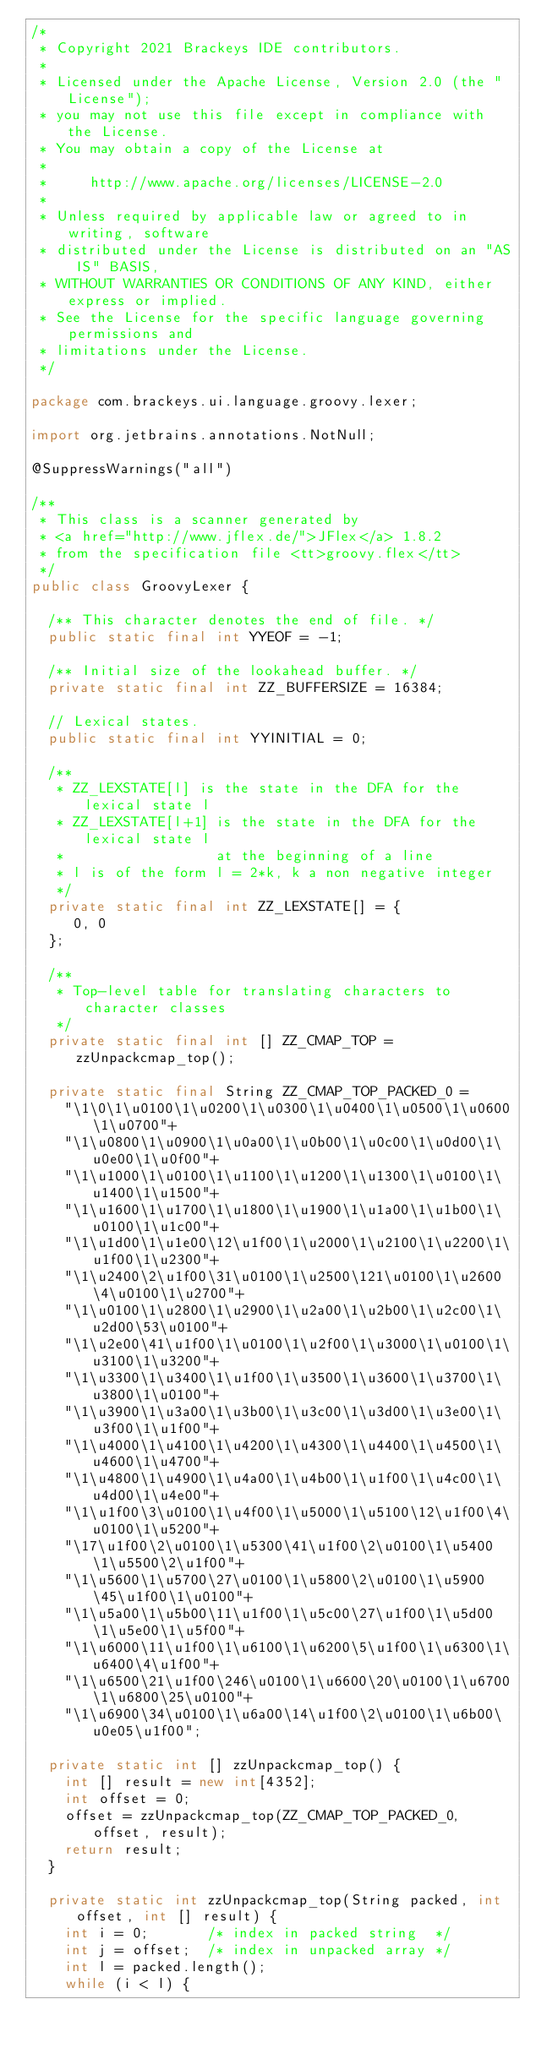Convert code to text. <code><loc_0><loc_0><loc_500><loc_500><_Java_>/*
 * Copyright 2021 Brackeys IDE contributors.
 *
 * Licensed under the Apache License, Version 2.0 (the "License");
 * you may not use this file except in compliance with the License.
 * You may obtain a copy of the License at
 *
 *     http://www.apache.org/licenses/LICENSE-2.0
 *
 * Unless required by applicable law or agreed to in writing, software
 * distributed under the License is distributed on an "AS IS" BASIS,
 * WITHOUT WARRANTIES OR CONDITIONS OF ANY KIND, either express or implied.
 * See the License for the specific language governing permissions and
 * limitations under the License.
 */

package com.brackeys.ui.language.groovy.lexer;

import org.jetbrains.annotations.NotNull;

@SuppressWarnings("all")

/**
 * This class is a scanner generated by
 * <a href="http://www.jflex.de/">JFlex</a> 1.8.2
 * from the specification file <tt>groovy.flex</tt>
 */
public class GroovyLexer {

  /** This character denotes the end of file. */
  public static final int YYEOF = -1;

  /** Initial size of the lookahead buffer. */
  private static final int ZZ_BUFFERSIZE = 16384;

  // Lexical states.
  public static final int YYINITIAL = 0;

  /**
   * ZZ_LEXSTATE[l] is the state in the DFA for the lexical state l
   * ZZ_LEXSTATE[l+1] is the state in the DFA for the lexical state l
   *                  at the beginning of a line
   * l is of the form l = 2*k, k a non negative integer
   */
  private static final int ZZ_LEXSTATE[] = {
     0, 0
  };

  /**
   * Top-level table for translating characters to character classes
   */
  private static final int [] ZZ_CMAP_TOP = zzUnpackcmap_top();

  private static final String ZZ_CMAP_TOP_PACKED_0 =
    "\1\0\1\u0100\1\u0200\1\u0300\1\u0400\1\u0500\1\u0600\1\u0700"+
    "\1\u0800\1\u0900\1\u0a00\1\u0b00\1\u0c00\1\u0d00\1\u0e00\1\u0f00"+
    "\1\u1000\1\u0100\1\u1100\1\u1200\1\u1300\1\u0100\1\u1400\1\u1500"+
    "\1\u1600\1\u1700\1\u1800\1\u1900\1\u1a00\1\u1b00\1\u0100\1\u1c00"+
    "\1\u1d00\1\u1e00\12\u1f00\1\u2000\1\u2100\1\u2200\1\u1f00\1\u2300"+
    "\1\u2400\2\u1f00\31\u0100\1\u2500\121\u0100\1\u2600\4\u0100\1\u2700"+
    "\1\u0100\1\u2800\1\u2900\1\u2a00\1\u2b00\1\u2c00\1\u2d00\53\u0100"+
    "\1\u2e00\41\u1f00\1\u0100\1\u2f00\1\u3000\1\u0100\1\u3100\1\u3200"+
    "\1\u3300\1\u3400\1\u1f00\1\u3500\1\u3600\1\u3700\1\u3800\1\u0100"+
    "\1\u3900\1\u3a00\1\u3b00\1\u3c00\1\u3d00\1\u3e00\1\u3f00\1\u1f00"+
    "\1\u4000\1\u4100\1\u4200\1\u4300\1\u4400\1\u4500\1\u4600\1\u4700"+
    "\1\u4800\1\u4900\1\u4a00\1\u4b00\1\u1f00\1\u4c00\1\u4d00\1\u4e00"+
    "\1\u1f00\3\u0100\1\u4f00\1\u5000\1\u5100\12\u1f00\4\u0100\1\u5200"+
    "\17\u1f00\2\u0100\1\u5300\41\u1f00\2\u0100\1\u5400\1\u5500\2\u1f00"+
    "\1\u5600\1\u5700\27\u0100\1\u5800\2\u0100\1\u5900\45\u1f00\1\u0100"+
    "\1\u5a00\1\u5b00\11\u1f00\1\u5c00\27\u1f00\1\u5d00\1\u5e00\1\u5f00"+
    "\1\u6000\11\u1f00\1\u6100\1\u6200\5\u1f00\1\u6300\1\u6400\4\u1f00"+
    "\1\u6500\21\u1f00\246\u0100\1\u6600\20\u0100\1\u6700\1\u6800\25\u0100"+
    "\1\u6900\34\u0100\1\u6a00\14\u1f00\2\u0100\1\u6b00\u0e05\u1f00";

  private static int [] zzUnpackcmap_top() {
    int [] result = new int[4352];
    int offset = 0;
    offset = zzUnpackcmap_top(ZZ_CMAP_TOP_PACKED_0, offset, result);
    return result;
  }

  private static int zzUnpackcmap_top(String packed, int offset, int [] result) {
    int i = 0;       /* index in packed string  */
    int j = offset;  /* index in unpacked array */
    int l = packed.length();
    while (i < l) {</code> 